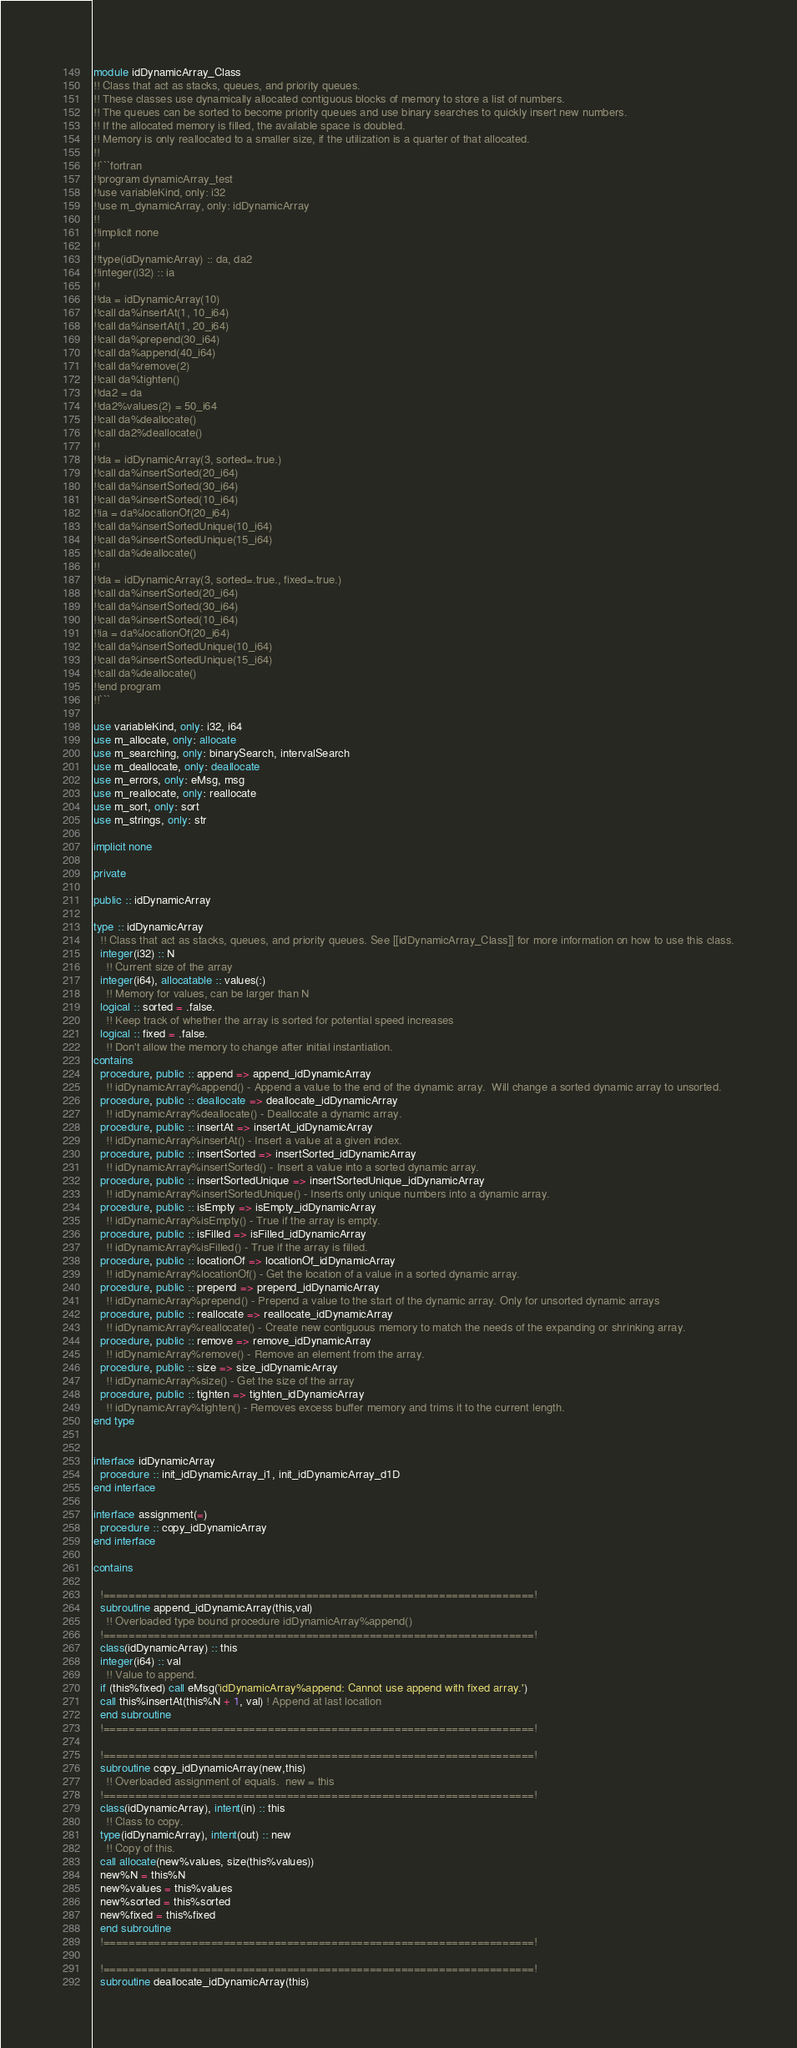<code> <loc_0><loc_0><loc_500><loc_500><_FORTRAN_>module idDynamicArray_Class
!! Class that act as stacks, queues, and priority queues.
!! These classes use dynamically allocated contiguous blocks of memory to store a list of numbers.
!! The queues can be sorted to become priority queues and use binary searches to quickly insert new numbers.
!! If the allocated memory is filled, the available space is doubled.
!! Memory is only reallocated to a smaller size, if the utilization is a quarter of that allocated.
!!
!!```fortran
!!program dynamicArray_test
!!use variableKind, only: i32
!!use m_dynamicArray, only: idDynamicArray
!!
!!implicit none
!!
!!type(idDynamicArray) :: da, da2
!!integer(i32) :: ia
!!
!!da = idDynamicArray(10)
!!call da%insertAt(1, 10_i64)
!!call da%insertAt(1, 20_i64)
!!call da%prepend(30_i64)
!!call da%append(40_i64)
!!call da%remove(2)
!!call da%tighten()
!!da2 = da
!!da2%values(2) = 50_i64
!!call da%deallocate()
!!call da2%deallocate()
!!
!!da = idDynamicArray(3, sorted=.true.)
!!call da%insertSorted(20_i64)
!!call da%insertSorted(30_i64)
!!call da%insertSorted(10_i64)
!!ia = da%locationOf(20_i64)
!!call da%insertSortedUnique(10_i64)
!!call da%insertSortedUnique(15_i64)
!!call da%deallocate()
!!
!!da = idDynamicArray(3, sorted=.true., fixed=.true.)
!!call da%insertSorted(20_i64)
!!call da%insertSorted(30_i64)
!!call da%insertSorted(10_i64)
!!ia = da%locationOf(20_i64)
!!call da%insertSortedUnique(10_i64)
!!call da%insertSortedUnique(15_i64)
!!call da%deallocate()
!!end program
!!```

use variableKind, only: i32, i64
use m_allocate, only: allocate
use m_searching, only: binarySearch, intervalSearch
use m_deallocate, only: deallocate
use m_errors, only: eMsg, msg
use m_reallocate, only: reallocate
use m_sort, only: sort
use m_strings, only: str

implicit none

private

public :: idDynamicArray

type :: idDynamicArray
  !! Class that act as stacks, queues, and priority queues. See [[idDynamicArray_Class]] for more information on how to use this class.
  integer(i32) :: N
    !! Current size of the array
  integer(i64), allocatable :: values(:)
    !! Memory for values, can be larger than N
  logical :: sorted = .false.
    !! Keep track of whether the array is sorted for potential speed increases
  logical :: fixed = .false.
    !! Don't allow the memory to change after initial instantiation.
contains
  procedure, public :: append => append_idDynamicArray
    !! idDynamicArray%append() - Append a value to the end of the dynamic array.  Will change a sorted dynamic array to unsorted.
  procedure, public :: deallocate => deallocate_idDynamicArray
    !! idDynamicArray%deallocate() - Deallocate a dynamic array.
  procedure, public :: insertAt => insertAt_idDynamicArray
    !! idDynamicArray%insertAt() - Insert a value at a given index.
  procedure, public :: insertSorted => insertSorted_idDynamicArray
    !! idDynamicArray%insertSorted() - Insert a value into a sorted dynamic array.
  procedure, public :: insertSortedUnique => insertSortedUnique_idDynamicArray
    !! idDynamicArray%insertSortedUnique() - Inserts only unique numbers into a dynamic array.
  procedure, public :: isEmpty => isEmpty_idDynamicArray
    !! idDynamicArray%isEmpty() - True if the array is empty.
  procedure, public :: isFilled => isFilled_idDynamicArray
    !! idDynamicArray%isFilled() - True if the array is filled.
  procedure, public :: locationOf => locationOf_idDynamicArray
    !! idDynamicArray%locationOf() - Get the location of a value in a sorted dynamic array.
  procedure, public :: prepend => prepend_idDynamicArray
    !! idDynamicArray%prepend() - Prepend a value to the start of the dynamic array. Only for unsorted dynamic arrays
  procedure, public :: reallocate => reallocate_idDynamicArray
    !! idDynamicArray%reallocate() - Create new contiguous memory to match the needs of the expanding or shrinking array.
  procedure, public :: remove => remove_idDynamicArray
    !! idDynamicArray%remove() - Remove an element from the array.
  procedure, public :: size => size_idDynamicArray
    !! idDynamicArray%size() - Get the size of the array
  procedure, public :: tighten => tighten_idDynamicArray
    !! idDynamicArray%tighten() - Removes excess buffer memory and trims it to the current length.
end type


interface idDynamicArray
  procedure :: init_idDynamicArray_i1, init_idDynamicArray_d1D
end interface

interface assignment(=)
  procedure :: copy_idDynamicArray
end interface

contains

  !====================================================================!
  subroutine append_idDynamicArray(this,val)
    !! Overloaded type bound procedure idDynamicArray%append()
  !====================================================================!
  class(idDynamicArray) :: this
  integer(i64) :: val
    !! Value to append.
  if (this%fixed) call eMsg('idDynamicArray%append: Cannot use append with fixed array.')
  call this%insertAt(this%N + 1, val) ! Append at last location
  end subroutine
  !====================================================================!

  !====================================================================!
  subroutine copy_idDynamicArray(new,this)
    !! Overloaded assignment of equals.  new = this
  !====================================================================!
  class(idDynamicArray), intent(in) :: this
    !! Class to copy.
  type(idDynamicArray), intent(out) :: new
    !! Copy of this.
  call allocate(new%values, size(this%values))
  new%N = this%N
  new%values = this%values
  new%sorted = this%sorted
  new%fixed = this%fixed
  end subroutine
  !====================================================================!

  !====================================================================!
  subroutine deallocate_idDynamicArray(this)</code> 